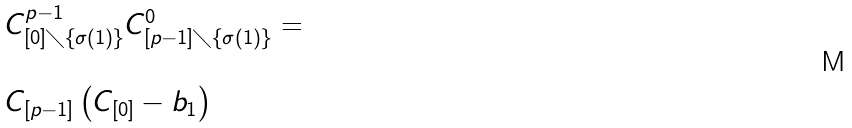Convert formula to latex. <formula><loc_0><loc_0><loc_500><loc_500>\begin{array} { l } C ^ { p - 1 } _ { [ 0 ] \diagdown \{ \sigma ( 1 ) \} } C ^ { 0 } _ { [ p - 1 ] \diagdown \{ \sigma ( 1 ) \} } = \\ \\ C _ { [ p - 1 ] } \left ( C _ { [ 0 ] } - b _ { 1 } \right ) \end{array}</formula> 